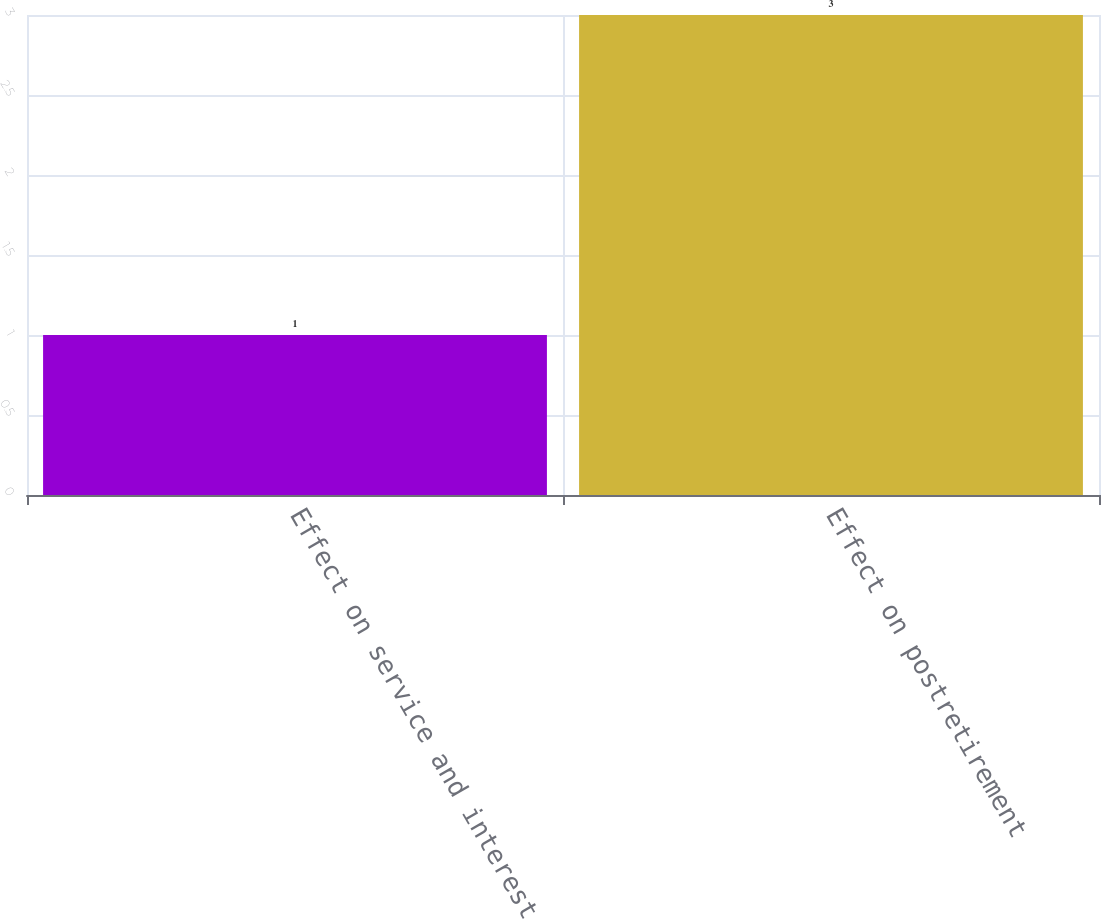<chart> <loc_0><loc_0><loc_500><loc_500><bar_chart><fcel>Effect on service and interest<fcel>Effect on postretirement<nl><fcel>1<fcel>3<nl></chart> 